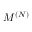<formula> <loc_0><loc_0><loc_500><loc_500>M ^ { ( N ) }</formula> 